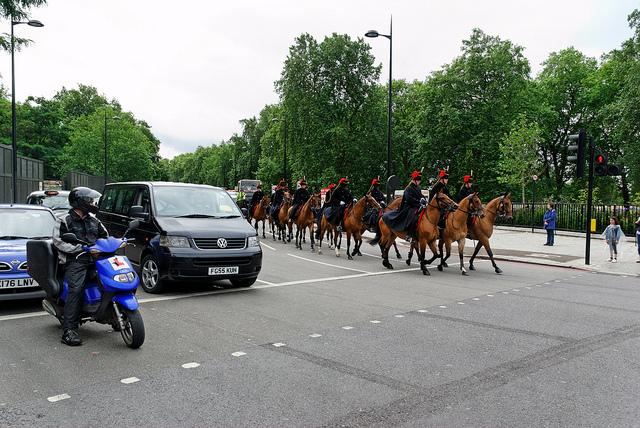What color is the van?
Quick response, please. Black. How many motorcycles are there?
Quick response, please. 1. What is on their heads?
Write a very short answer. Hats. What are the horses following?
Keep it brief. Parade. What kind of vehicle is the officer riding?
Be succinct. Horse. Of the two methods of locomotion you perceive in the image, which can go faster?
Keep it brief. Car. What are all of the people riding on?
Answer briefly. Horses. How many riders mounted on horse are in this group?
Give a very brief answer. 9. What are the people in black riding?
Be succinct. Horses. 